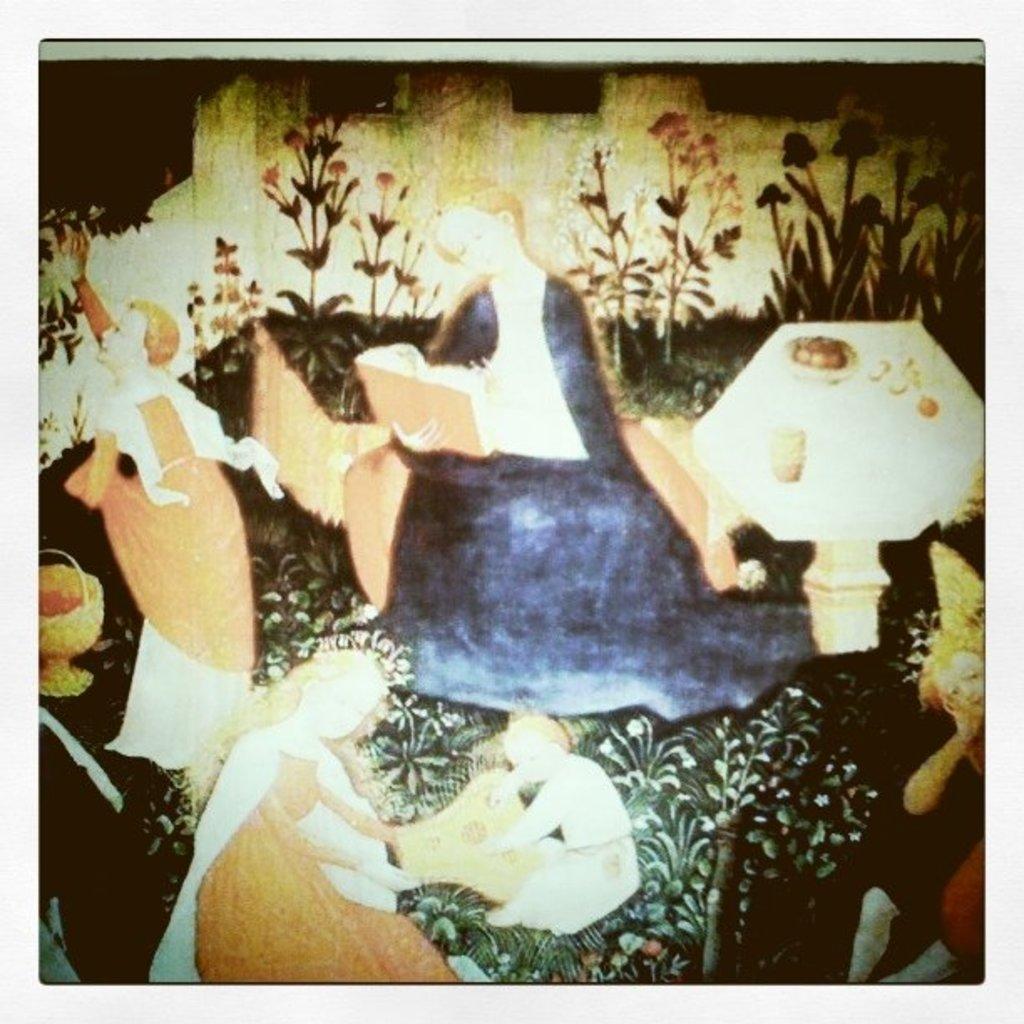Can you describe this image briefly? This is a painting. In the painting there are few people ,plants, table, sofa are there. Here a lady holding a book is reading something. 